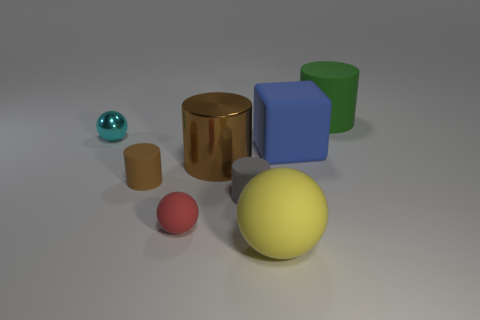There is a rubber block that is the same size as the yellow rubber sphere; what is its color?
Your response must be concise. Blue. Is there another shiny block that has the same color as the large block?
Give a very brief answer. No. Is the number of large matte cubes that are in front of the large brown metal cylinder less than the number of yellow rubber balls that are behind the small red rubber object?
Keep it short and to the point. No. The large thing that is in front of the block and right of the metallic cylinder is made of what material?
Your response must be concise. Rubber. There is a gray rubber thing; is its shape the same as the yellow object that is in front of the large rubber cube?
Ensure brevity in your answer.  No. How many other objects are there of the same size as the yellow matte object?
Your response must be concise. 3. Are there more large blue rubber blocks than small green cylinders?
Provide a succinct answer. Yes. How many objects are behind the large blue rubber object and on the right side of the gray thing?
Give a very brief answer. 1. There is a brown thing on the left side of the large cylinder that is in front of the large matte thing behind the small shiny ball; what is its shape?
Make the answer very short. Cylinder. Is there any other thing that is the same shape as the cyan thing?
Give a very brief answer. Yes. 